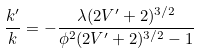Convert formula to latex. <formula><loc_0><loc_0><loc_500><loc_500>\frac { k ^ { \prime } } { k } = - \frac { \lambda ( 2 V ^ { \prime } + 2 ) ^ { 3 / 2 } } { \phi ^ { 2 } ( 2 V ^ { \prime } + 2 ) ^ { 3 / 2 } - 1 }</formula> 